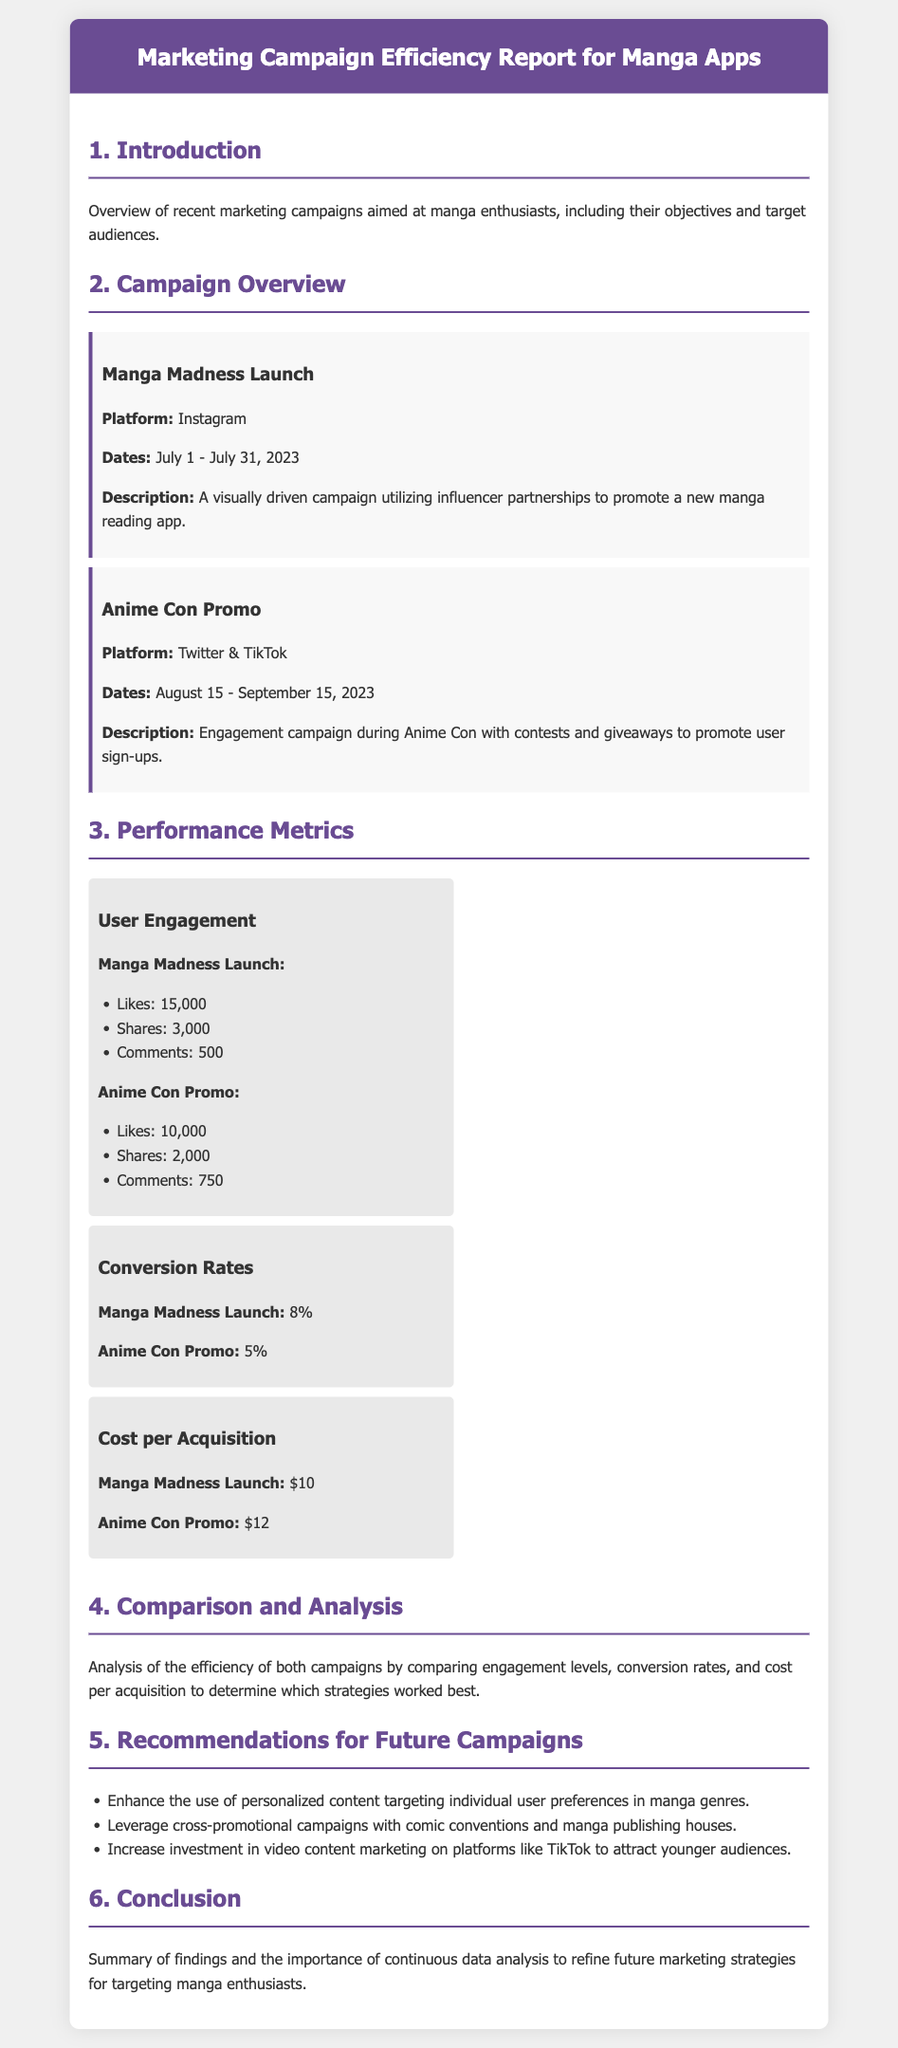What was the platform for the Manga Madness Launch campaign? The platform for the Manga Madness Launch campaign is found in the campaign overview section of the document.
Answer: Instagram What were the dates for the Anime Con Promo campaign? The dates for the Anime Con Promo campaign are listed in the campaign overview section.
Answer: August 15 - September 15, 2023 How many comments did the Manga Madness Launch receive? The number of comments for the Manga Madness Launch is specified under the user engagement metrics.
Answer: 500 What is the conversion rate for the Anime Con Promo? The conversion rate for the Anime Con Promo can be found in the performance metrics section.
Answer: 5% What is the cost per acquisition for the Manga Madness Launch? The cost per acquisition for the Manga Madness Launch is provided in the performance metrics section.
Answer: $10 Which campaign had a higher user engagement? This question requires reasoning over the user engagement metrics provided for both campaigns.
Answer: Manga Madness Launch What is one recommendation for future campaigns? Recommendations are listed in the document under future campaign strategies.
Answer: Enhance the use of personalized content targeting individual user preferences in manga genres What section summarizes the findings? The section that provides a summary of findings is clearly indicated in the document's structure.
Answer: Conclusion 